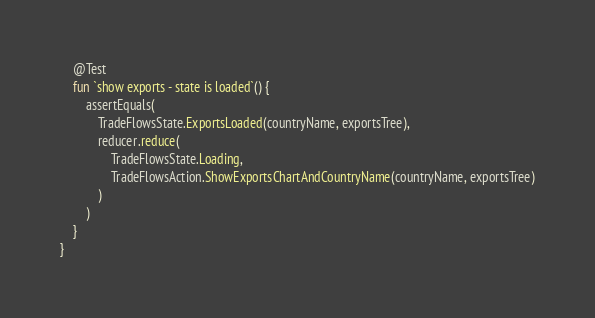Convert code to text. <code><loc_0><loc_0><loc_500><loc_500><_Kotlin_>    @Test
    fun `show exports - state is loaded`() {
        assertEquals(
            TradeFlowsState.ExportsLoaded(countryName, exportsTree),
            reducer.reduce(
                TradeFlowsState.Loading,
                TradeFlowsAction.ShowExportsChartAndCountryName(countryName, exportsTree)
            )
        )
    }
}</code> 